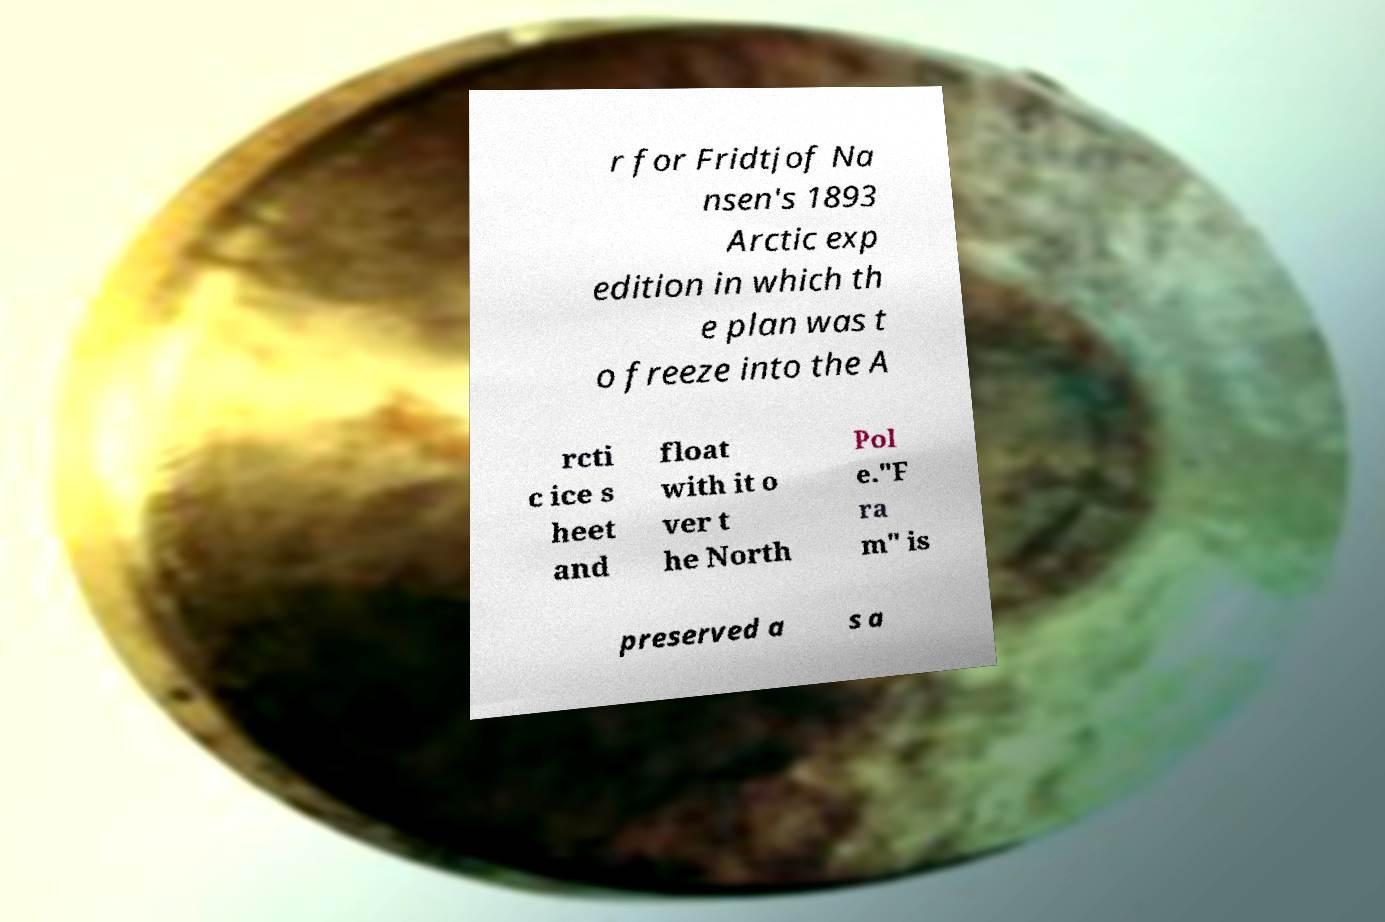Can you accurately transcribe the text from the provided image for me? r for Fridtjof Na nsen's 1893 Arctic exp edition in which th e plan was t o freeze into the A rcti c ice s heet and float with it o ver t he North Pol e."F ra m" is preserved a s a 